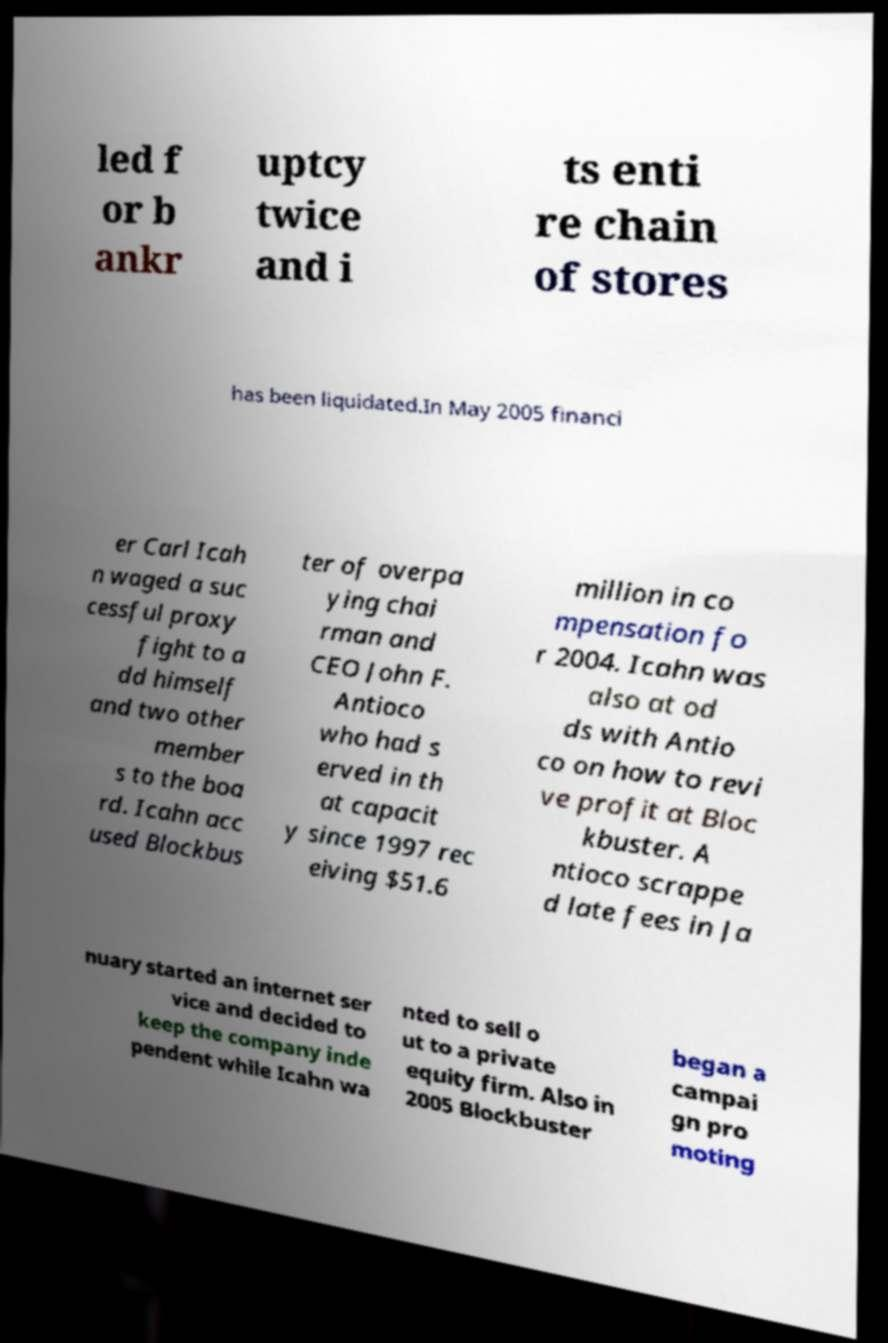There's text embedded in this image that I need extracted. Can you transcribe it verbatim? led f or b ankr uptcy twice and i ts enti re chain of stores has been liquidated.In May 2005 financi er Carl Icah n waged a suc cessful proxy fight to a dd himself and two other member s to the boa rd. Icahn acc used Blockbus ter of overpa ying chai rman and CEO John F. Antioco who had s erved in th at capacit y since 1997 rec eiving $51.6 million in co mpensation fo r 2004. Icahn was also at od ds with Antio co on how to revi ve profit at Bloc kbuster. A ntioco scrappe d late fees in Ja nuary started an internet ser vice and decided to keep the company inde pendent while Icahn wa nted to sell o ut to a private equity firm. Also in 2005 Blockbuster began a campai gn pro moting 